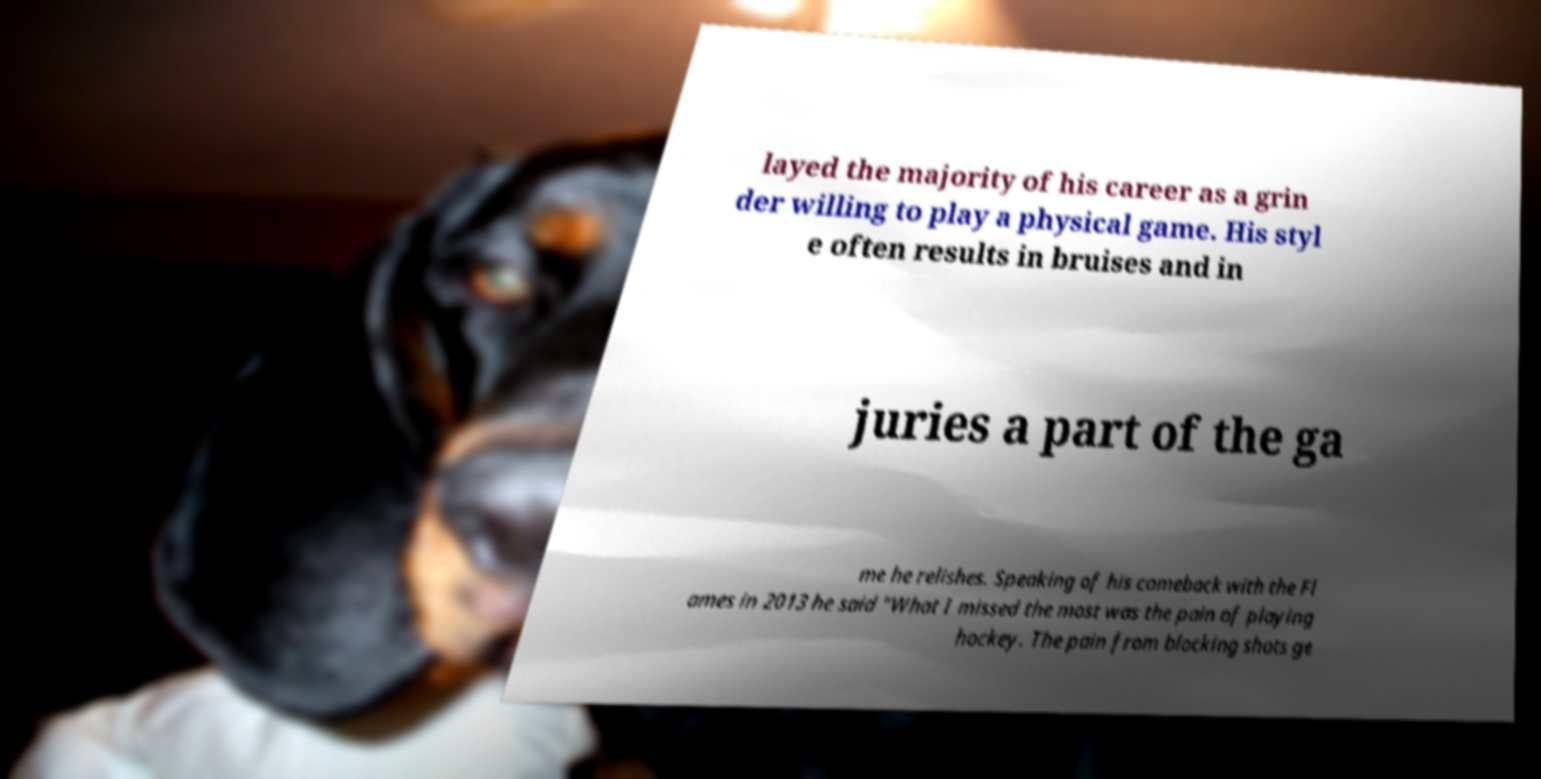Please read and relay the text visible in this image. What does it say? layed the majority of his career as a grin der willing to play a physical game. His styl e often results in bruises and in juries a part of the ga me he relishes. Speaking of his comeback with the Fl ames in 2013 he said "What I missed the most was the pain of playing hockey. The pain from blocking shots ge 